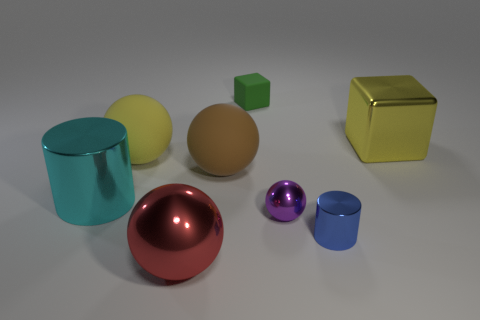How many other things are the same color as the large block?
Provide a succinct answer. 1. There is a metallic sphere right of the matte block; does it have the same size as the cyan shiny cylinder?
Give a very brief answer. No. There is a object that is right of the tiny green rubber object and on the left side of the tiny metal cylinder; what size is it?
Provide a short and direct response. Small. What number of other objects are there of the same shape as the tiny green thing?
Offer a very short reply. 1. What number of other objects are the same material as the small green block?
Offer a very short reply. 2. There is a yellow thing that is the same shape as the tiny purple object; what is its size?
Keep it short and to the point. Large. Do the big shiny block and the small matte cube have the same color?
Provide a short and direct response. No. There is a sphere that is both left of the large brown sphere and in front of the cyan metallic thing; what is its color?
Ensure brevity in your answer.  Red. What number of objects are either large yellow objects that are left of the green matte thing or big yellow rubber objects?
Offer a very short reply. 1. There is another shiny object that is the same shape as the red thing; what color is it?
Offer a very short reply. Purple. 